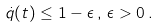<formula> <loc_0><loc_0><loc_500><loc_500>\dot { q } ( t ) \leq 1 - \epsilon \, , \, \epsilon > 0 \, .</formula> 